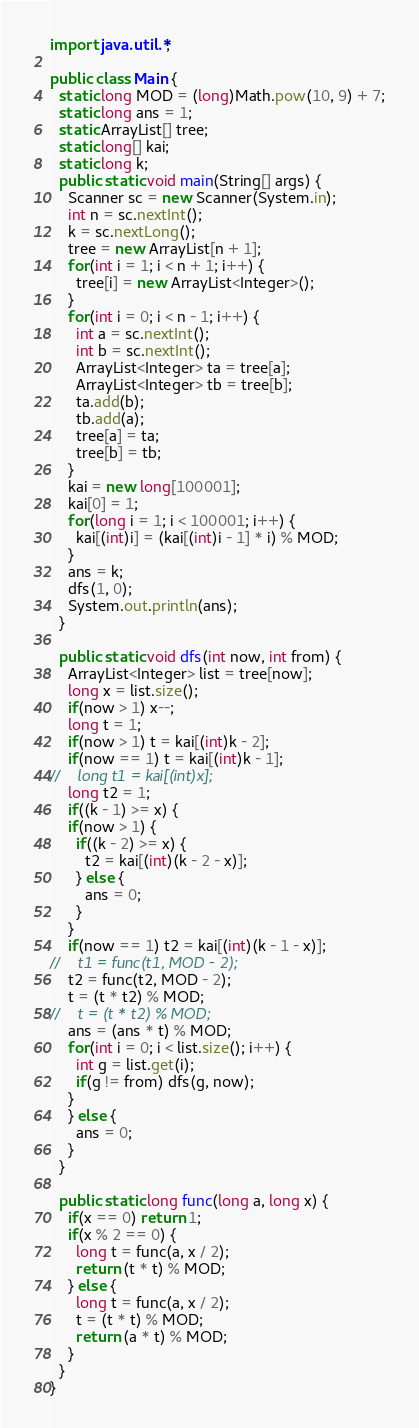Convert code to text. <code><loc_0><loc_0><loc_500><loc_500><_Java_>import java.util.*;

public class Main {
  static long MOD = (long)Math.pow(10, 9) + 7;
  static long ans = 1;
  static ArrayList[] tree;
  static long[] kai;
  static long k;
  public static void main(String[] args) {
    Scanner sc = new Scanner(System.in);
    int n = sc.nextInt();
    k = sc.nextLong();
    tree = new ArrayList[n + 1];
    for(int i = 1; i < n + 1; i++) {
      tree[i] = new ArrayList<Integer>();
    }
    for(int i = 0; i < n - 1; i++) {
      int a = sc.nextInt();
      int b = sc.nextInt();
      ArrayList<Integer> ta = tree[a];
      ArrayList<Integer> tb = tree[b];
      ta.add(b);
      tb.add(a);
      tree[a] = ta;
      tree[b] = tb;
    }
    kai = new long[100001];
    kai[0] = 1;
    for(long i = 1; i < 100001; i++) {
      kai[(int)i] = (kai[(int)i - 1] * i) % MOD;
    }
    ans = k;
    dfs(1, 0);
    System.out.println(ans);
  }

  public static void dfs(int now, int from) {
    ArrayList<Integer> list = tree[now];
    long x = list.size();
    if(now > 1) x--;
    long t = 1;
    if(now > 1) t = kai[(int)k - 2];
    if(now == 1) t = kai[(int)k - 1];
//    long t1 = kai[(int)x];
    long t2 = 1;
    if((k - 1) >= x) {
    if(now > 1) {
      if((k - 2) >= x) {
        t2 = kai[(int)(k - 2 - x)];
      } else {
        ans = 0;
      }
    }
    if(now == 1) t2 = kai[(int)(k - 1 - x)];
//    t1 = func(t1, MOD - 2);
    t2 = func(t2, MOD - 2);
    t = (t * t2) % MOD;
//    t = (t * t2) % MOD;
    ans = (ans * t) % MOD;
    for(int i = 0; i < list.size(); i++) {
      int g = list.get(i);
      if(g != from) dfs(g, now);
    }
    } else {
      ans = 0;
    }
  }

  public static long func(long a, long x) {
    if(x == 0) return 1;
    if(x % 2 == 0) {
      long t = func(a, x / 2);
      return (t * t) % MOD;
    } else {
      long t = func(a, x / 2);
      t = (t * t) % MOD;
      return (a * t) % MOD;      
    }
  }
}</code> 